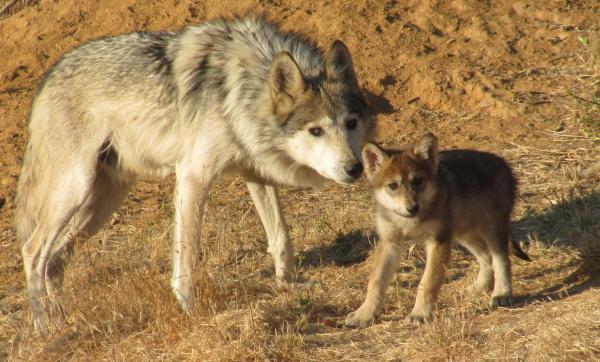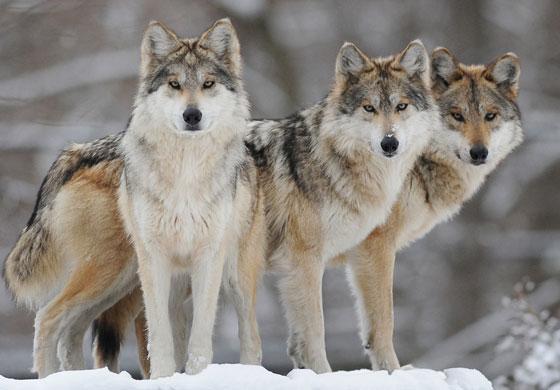The first image is the image on the left, the second image is the image on the right. Considering the images on both sides, is "One image shows a leftward-facing wolf standing in a green grassy area." valid? Answer yes or no. No. The first image is the image on the left, the second image is the image on the right. Analyze the images presented: Is the assertion "The wolf in one of the images is standing in the green grass." valid? Answer yes or no. No. The first image is the image on the left, the second image is the image on the right. Analyze the images presented: Is the assertion "The wolf in the right image is facing towards the left." valid? Answer yes or no. No. The first image is the image on the left, the second image is the image on the right. Evaluate the accuracy of this statement regarding the images: "Each image contains exactly one wolf, and the righthand wolf faces leftward.". Is it true? Answer yes or no. No. 